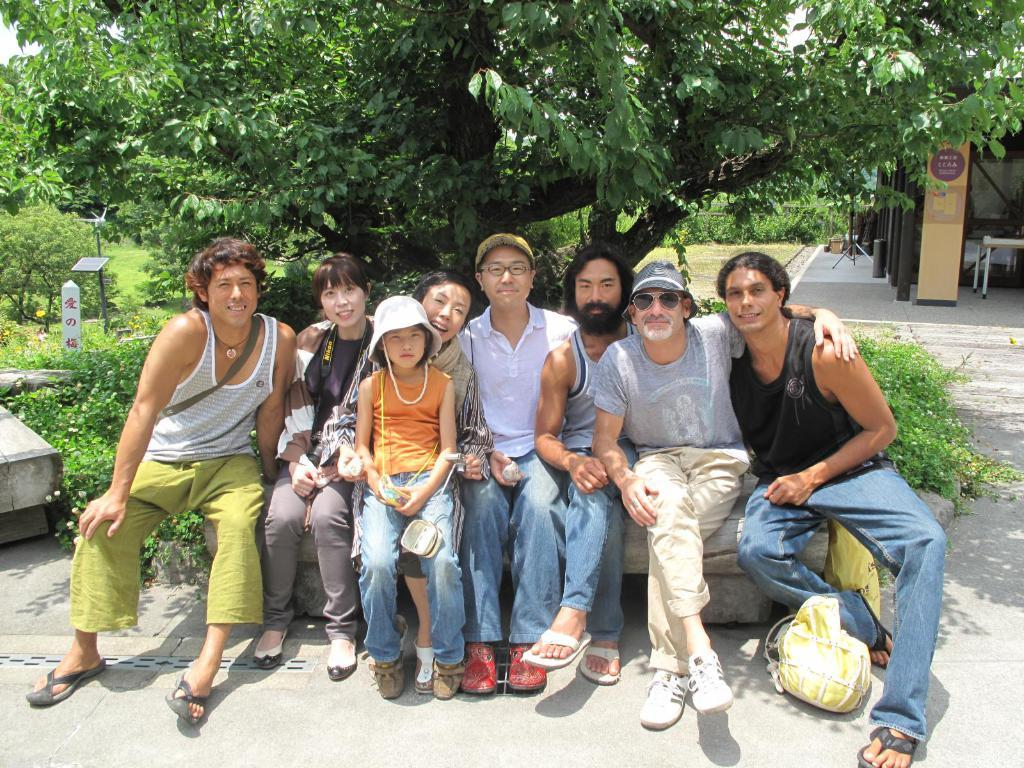How many groups of persons can be seen in the image? There are groups of persons in the image. What are the persons sitting on? The persons are sitting on a stone. What are the persons holding in their hands? The persons are holding objects. What is located beside the persons? There is a bag beside the persons. What can be seen in the background of the image? There are trees and a table in the background of the image. What type of sign can be seen hanging from the tree in the image? There is no sign present in the image; it only features groups of persons sitting on a stone, holding objects, and a bag beside them, with trees and a table in the background. 